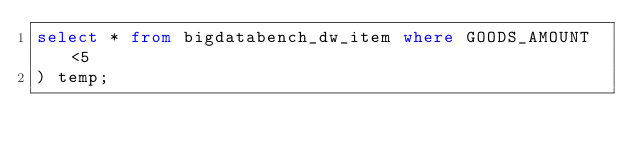Convert code to text. <code><loc_0><loc_0><loc_500><loc_500><_SQL_>select * from bigdatabench_dw_item where GOODS_AMOUNT <5
) temp;
</code> 